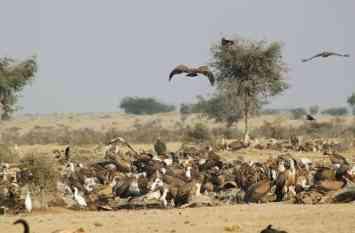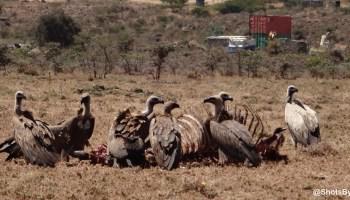The first image is the image on the left, the second image is the image on the right. Given the left and right images, does the statement "There is at least one bird with extended wings in the image on the right." hold true? Answer yes or no. No. 